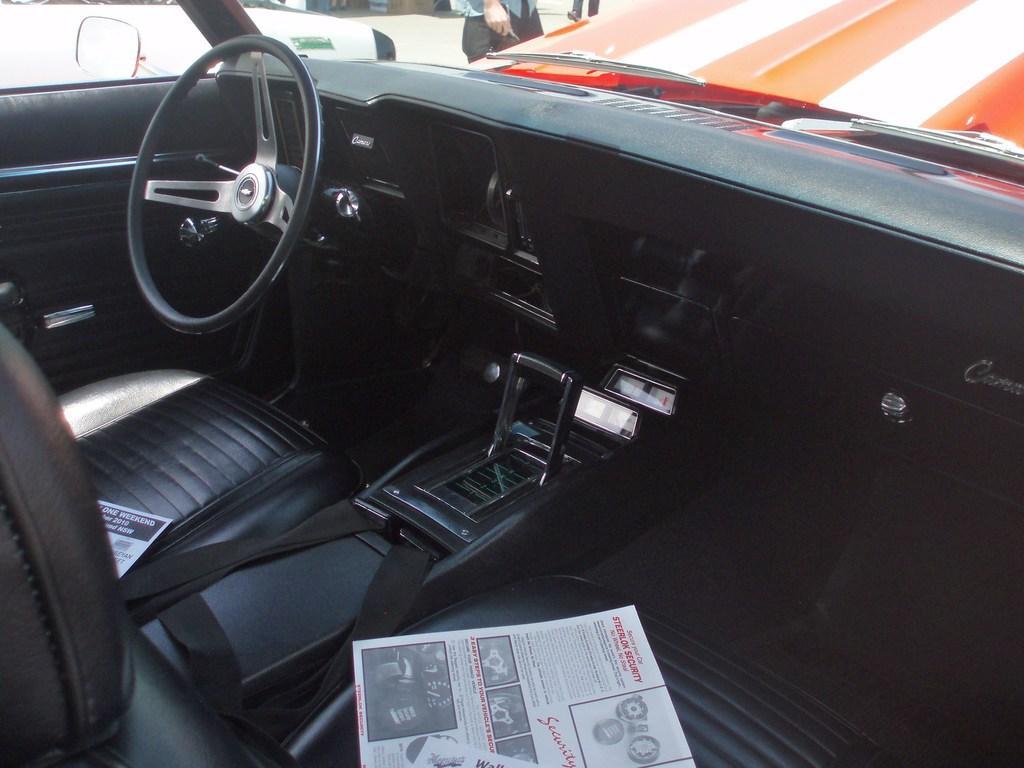How would you summarize this image in a sentence or two? Here we can see the inside view of a car and there are two newspapers on the seats. Through the car glass door we can see few persons,road and other objects. 